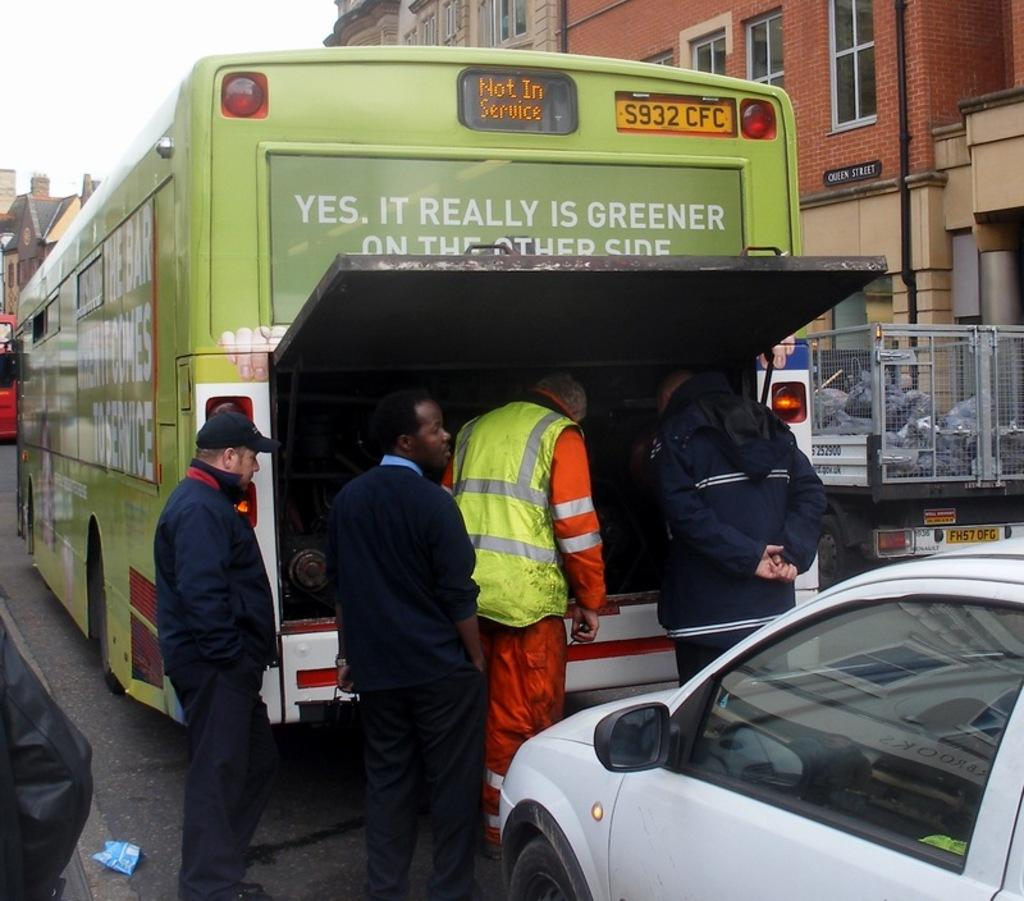<image>
Create a compact narrative representing the image presented. A green city bus states, "Yes, it really is greener on the other side". 